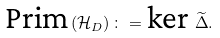Convert formula to latex. <formula><loc_0><loc_0><loc_500><loc_500>\text {Prim} \left ( \mathcal { H } _ { D } \right ) \colon = \text {ker } \widetilde { \Delta } .</formula> 